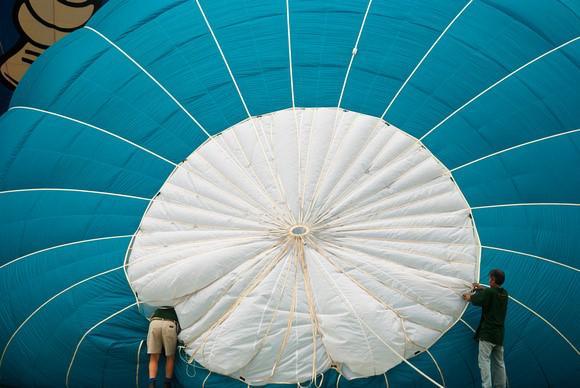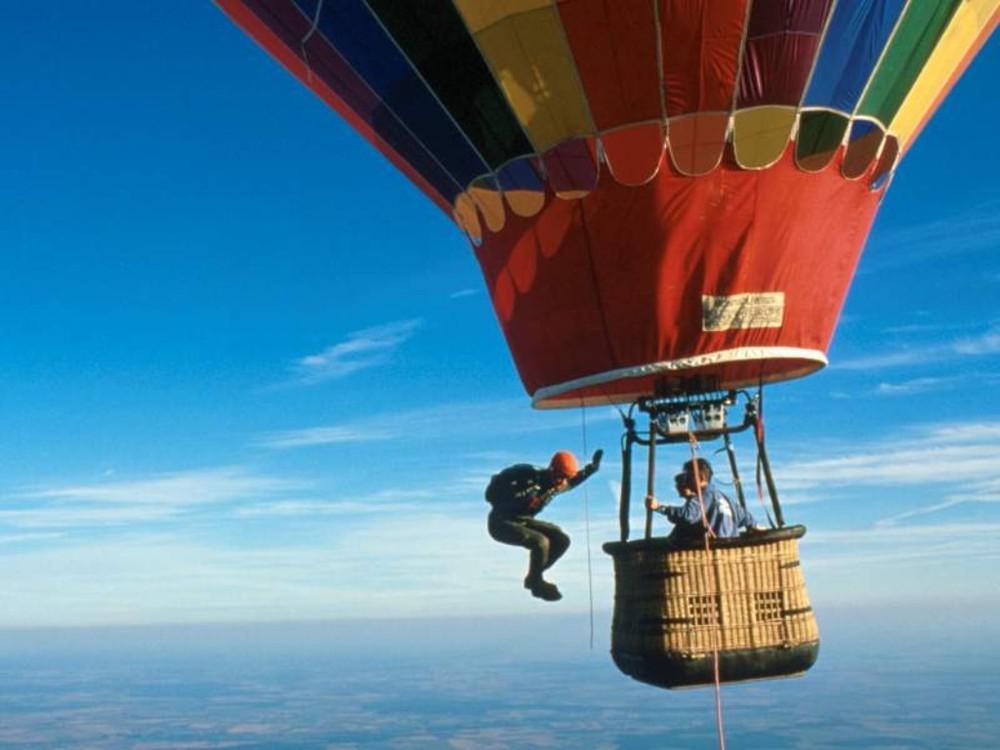The first image is the image on the left, the second image is the image on the right. Examine the images to the left and right. Is the description "There is a skydiver in the image on the right." accurate? Answer yes or no. Yes. 